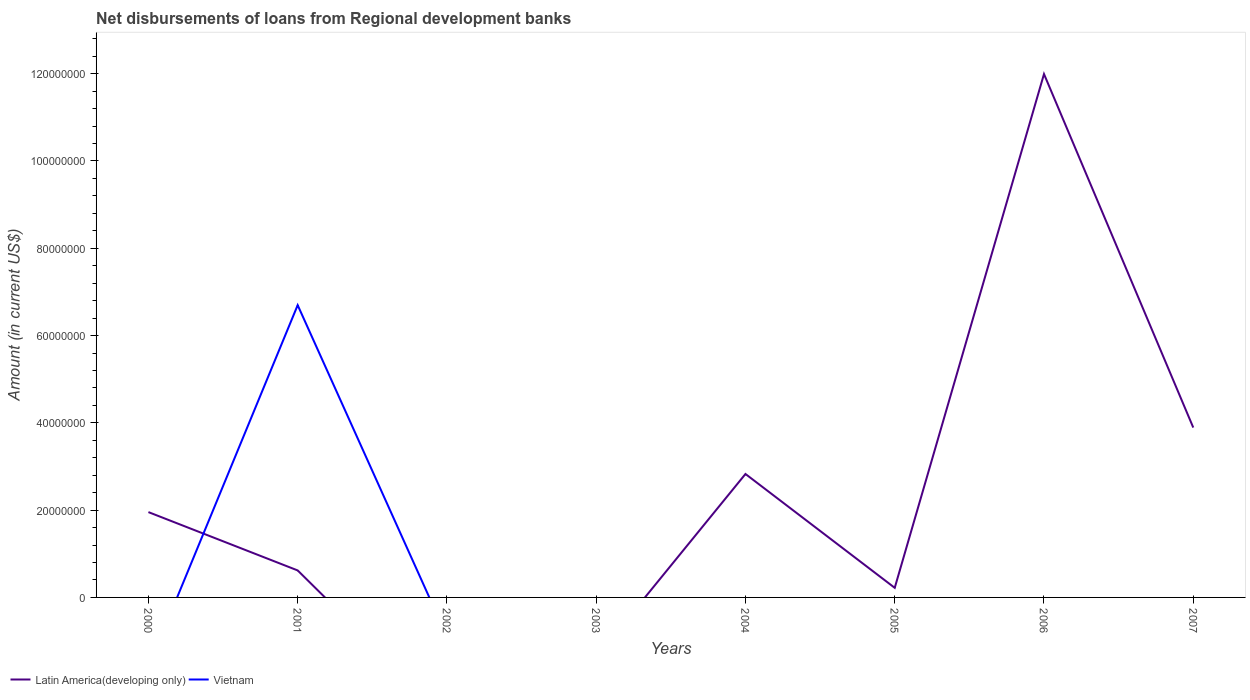How many different coloured lines are there?
Offer a very short reply. 2. Across all years, what is the maximum amount of disbursements of loans from regional development banks in Vietnam?
Your answer should be compact. 0. What is the total amount of disbursements of loans from regional development banks in Latin America(developing only) in the graph?
Your response must be concise. -2.21e+07. What is the difference between the highest and the second highest amount of disbursements of loans from regional development banks in Vietnam?
Make the answer very short. 6.70e+07. What is the difference between the highest and the lowest amount of disbursements of loans from regional development banks in Latin America(developing only)?
Offer a very short reply. 3. Is the amount of disbursements of loans from regional development banks in Latin America(developing only) strictly greater than the amount of disbursements of loans from regional development banks in Vietnam over the years?
Provide a short and direct response. No. What is the difference between two consecutive major ticks on the Y-axis?
Make the answer very short. 2.00e+07. Are the values on the major ticks of Y-axis written in scientific E-notation?
Your answer should be very brief. No. Does the graph contain any zero values?
Ensure brevity in your answer.  Yes. How many legend labels are there?
Offer a terse response. 2. How are the legend labels stacked?
Provide a succinct answer. Horizontal. What is the title of the graph?
Make the answer very short. Net disbursements of loans from Regional development banks. Does "Canada" appear as one of the legend labels in the graph?
Your response must be concise. No. What is the label or title of the Y-axis?
Offer a terse response. Amount (in current US$). What is the Amount (in current US$) in Latin America(developing only) in 2000?
Ensure brevity in your answer.  1.95e+07. What is the Amount (in current US$) in Vietnam in 2000?
Your answer should be compact. 0. What is the Amount (in current US$) in Latin America(developing only) in 2001?
Offer a very short reply. 6.19e+06. What is the Amount (in current US$) in Vietnam in 2001?
Your answer should be very brief. 6.70e+07. What is the Amount (in current US$) in Vietnam in 2003?
Ensure brevity in your answer.  0. What is the Amount (in current US$) of Latin America(developing only) in 2004?
Give a very brief answer. 2.83e+07. What is the Amount (in current US$) of Vietnam in 2004?
Your answer should be very brief. 0. What is the Amount (in current US$) in Latin America(developing only) in 2005?
Ensure brevity in your answer.  2.20e+06. What is the Amount (in current US$) of Vietnam in 2005?
Offer a very short reply. 0. What is the Amount (in current US$) of Latin America(developing only) in 2006?
Provide a succinct answer. 1.20e+08. What is the Amount (in current US$) in Vietnam in 2006?
Give a very brief answer. 0. What is the Amount (in current US$) in Latin America(developing only) in 2007?
Offer a terse response. 3.89e+07. What is the Amount (in current US$) of Vietnam in 2007?
Your answer should be very brief. 0. Across all years, what is the maximum Amount (in current US$) of Latin America(developing only)?
Make the answer very short. 1.20e+08. Across all years, what is the maximum Amount (in current US$) of Vietnam?
Provide a short and direct response. 6.70e+07. What is the total Amount (in current US$) of Latin America(developing only) in the graph?
Your answer should be very brief. 2.15e+08. What is the total Amount (in current US$) of Vietnam in the graph?
Ensure brevity in your answer.  6.70e+07. What is the difference between the Amount (in current US$) in Latin America(developing only) in 2000 and that in 2001?
Offer a terse response. 1.34e+07. What is the difference between the Amount (in current US$) in Latin America(developing only) in 2000 and that in 2004?
Keep it short and to the point. -8.73e+06. What is the difference between the Amount (in current US$) of Latin America(developing only) in 2000 and that in 2005?
Give a very brief answer. 1.73e+07. What is the difference between the Amount (in current US$) of Latin America(developing only) in 2000 and that in 2006?
Provide a short and direct response. -1.00e+08. What is the difference between the Amount (in current US$) in Latin America(developing only) in 2000 and that in 2007?
Keep it short and to the point. -1.94e+07. What is the difference between the Amount (in current US$) in Latin America(developing only) in 2001 and that in 2004?
Give a very brief answer. -2.21e+07. What is the difference between the Amount (in current US$) in Latin America(developing only) in 2001 and that in 2005?
Make the answer very short. 3.99e+06. What is the difference between the Amount (in current US$) of Latin America(developing only) in 2001 and that in 2006?
Your answer should be very brief. -1.14e+08. What is the difference between the Amount (in current US$) of Latin America(developing only) in 2001 and that in 2007?
Give a very brief answer. -3.27e+07. What is the difference between the Amount (in current US$) of Latin America(developing only) in 2004 and that in 2005?
Give a very brief answer. 2.61e+07. What is the difference between the Amount (in current US$) of Latin America(developing only) in 2004 and that in 2006?
Ensure brevity in your answer.  -9.16e+07. What is the difference between the Amount (in current US$) in Latin America(developing only) in 2004 and that in 2007?
Ensure brevity in your answer.  -1.06e+07. What is the difference between the Amount (in current US$) in Latin America(developing only) in 2005 and that in 2006?
Offer a terse response. -1.18e+08. What is the difference between the Amount (in current US$) in Latin America(developing only) in 2005 and that in 2007?
Offer a very short reply. -3.67e+07. What is the difference between the Amount (in current US$) of Latin America(developing only) in 2006 and that in 2007?
Make the answer very short. 8.10e+07. What is the difference between the Amount (in current US$) of Latin America(developing only) in 2000 and the Amount (in current US$) of Vietnam in 2001?
Offer a very short reply. -4.74e+07. What is the average Amount (in current US$) in Latin America(developing only) per year?
Offer a terse response. 2.69e+07. What is the average Amount (in current US$) in Vietnam per year?
Provide a short and direct response. 8.37e+06. In the year 2001, what is the difference between the Amount (in current US$) of Latin America(developing only) and Amount (in current US$) of Vietnam?
Keep it short and to the point. -6.08e+07. What is the ratio of the Amount (in current US$) in Latin America(developing only) in 2000 to that in 2001?
Your answer should be compact. 3.16. What is the ratio of the Amount (in current US$) of Latin America(developing only) in 2000 to that in 2004?
Offer a terse response. 0.69. What is the ratio of the Amount (in current US$) in Latin America(developing only) in 2000 to that in 2005?
Ensure brevity in your answer.  8.89. What is the ratio of the Amount (in current US$) in Latin America(developing only) in 2000 to that in 2006?
Provide a succinct answer. 0.16. What is the ratio of the Amount (in current US$) in Latin America(developing only) in 2000 to that in 2007?
Offer a very short reply. 0.5. What is the ratio of the Amount (in current US$) in Latin America(developing only) in 2001 to that in 2004?
Your answer should be very brief. 0.22. What is the ratio of the Amount (in current US$) of Latin America(developing only) in 2001 to that in 2005?
Provide a short and direct response. 2.81. What is the ratio of the Amount (in current US$) in Latin America(developing only) in 2001 to that in 2006?
Offer a terse response. 0.05. What is the ratio of the Amount (in current US$) of Latin America(developing only) in 2001 to that in 2007?
Keep it short and to the point. 0.16. What is the ratio of the Amount (in current US$) in Latin America(developing only) in 2004 to that in 2005?
Make the answer very short. 12.86. What is the ratio of the Amount (in current US$) in Latin America(developing only) in 2004 to that in 2006?
Your response must be concise. 0.24. What is the ratio of the Amount (in current US$) in Latin America(developing only) in 2004 to that in 2007?
Your response must be concise. 0.73. What is the ratio of the Amount (in current US$) of Latin America(developing only) in 2005 to that in 2006?
Give a very brief answer. 0.02. What is the ratio of the Amount (in current US$) in Latin America(developing only) in 2005 to that in 2007?
Ensure brevity in your answer.  0.06. What is the ratio of the Amount (in current US$) in Latin America(developing only) in 2006 to that in 2007?
Provide a short and direct response. 3.08. What is the difference between the highest and the second highest Amount (in current US$) of Latin America(developing only)?
Make the answer very short. 8.10e+07. What is the difference between the highest and the lowest Amount (in current US$) of Latin America(developing only)?
Provide a succinct answer. 1.20e+08. What is the difference between the highest and the lowest Amount (in current US$) of Vietnam?
Your answer should be compact. 6.70e+07. 